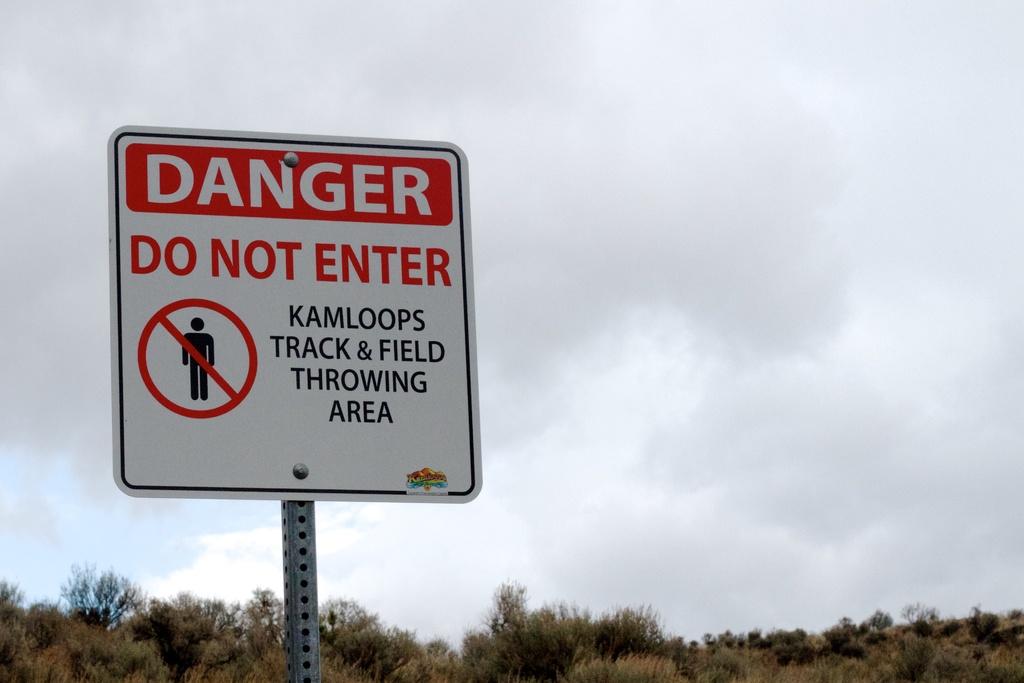What is this warning?
Your answer should be very brief. Do not enter. What area is this?
Ensure brevity in your answer.  Kamloops track & field throwing area. 